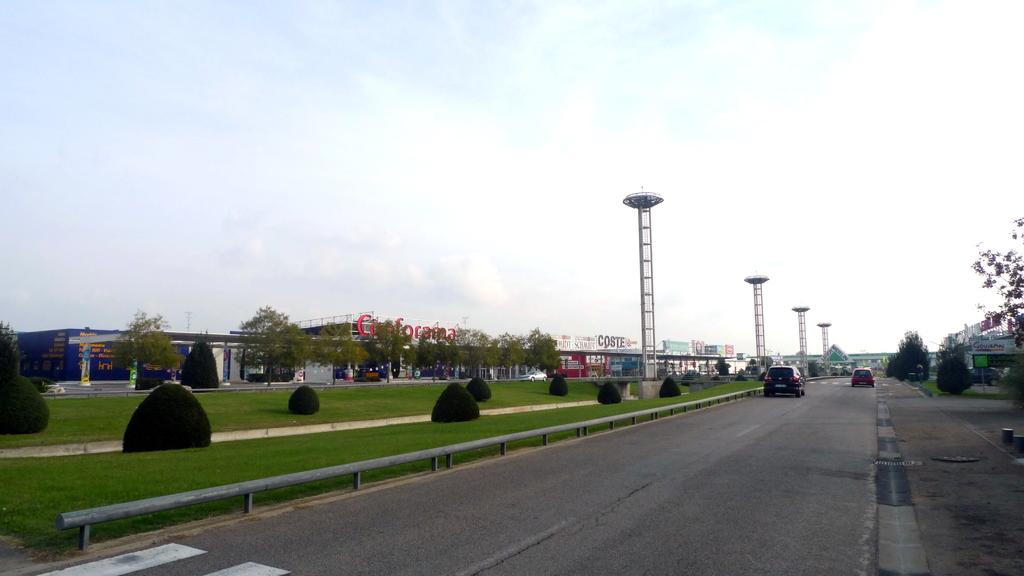What can be seen on the road in the image? There are motor vehicles on the road in the image. What is visible on the ground in the image? The ground is visible in the image. What type of vegetation is present in the image? There are bushes and trees visible in the image. What structures are present to separate or protect areas in the image? Barriers are present in the image. What type of buildings can be seen in the image? There are buildings in the image. What signs are visible in the image? Name boards are visible in the image. What tall structures can be seen in the image? Towers are present in the image. What is visible in the sky in the image? The sky is visible in the image, and clouds are present in the sky. How does the tub move around in the image? There is no tub present in the image. What type of show can be seen taking place in the image? There is no show taking place in the image. 